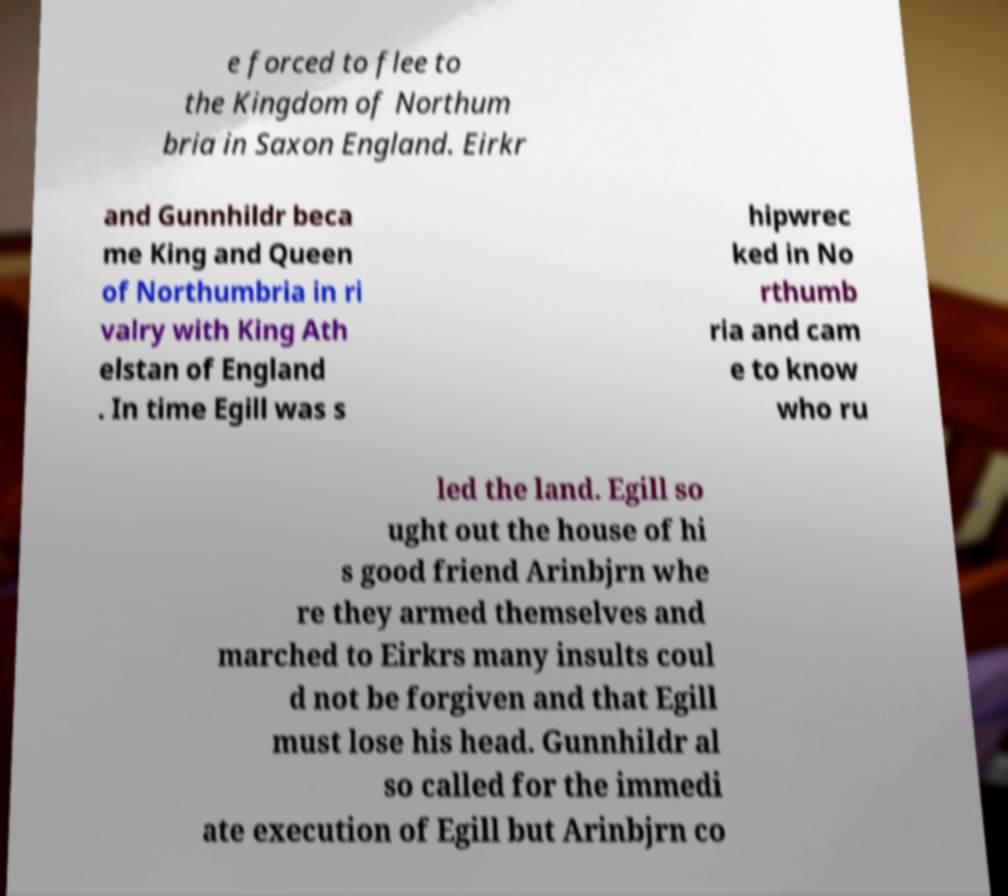Please identify and transcribe the text found in this image. e forced to flee to the Kingdom of Northum bria in Saxon England. Eirkr and Gunnhildr beca me King and Queen of Northumbria in ri valry with King Ath elstan of England . In time Egill was s hipwrec ked in No rthumb ria and cam e to know who ru led the land. Egill so ught out the house of hi s good friend Arinbjrn whe re they armed themselves and marched to Eirkrs many insults coul d not be forgiven and that Egill must lose his head. Gunnhildr al so called for the immedi ate execution of Egill but Arinbjrn co 